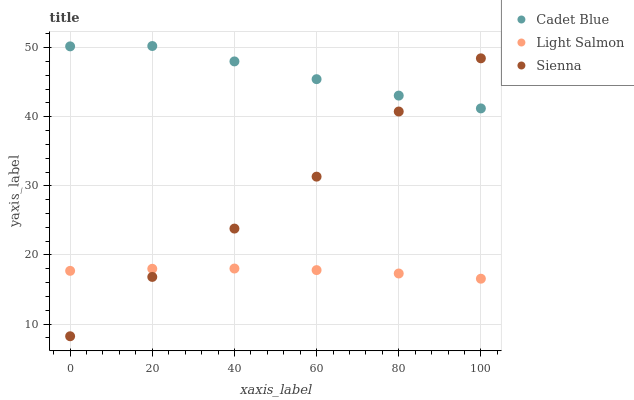Does Light Salmon have the minimum area under the curve?
Answer yes or no. Yes. Does Cadet Blue have the maximum area under the curve?
Answer yes or no. Yes. Does Cadet Blue have the minimum area under the curve?
Answer yes or no. No. Does Light Salmon have the maximum area under the curve?
Answer yes or no. No. Is Light Salmon the smoothest?
Answer yes or no. Yes. Is Sienna the roughest?
Answer yes or no. Yes. Is Cadet Blue the smoothest?
Answer yes or no. No. Is Cadet Blue the roughest?
Answer yes or no. No. Does Sienna have the lowest value?
Answer yes or no. Yes. Does Light Salmon have the lowest value?
Answer yes or no. No. Does Cadet Blue have the highest value?
Answer yes or no. Yes. Does Light Salmon have the highest value?
Answer yes or no. No. Is Light Salmon less than Cadet Blue?
Answer yes or no. Yes. Is Cadet Blue greater than Light Salmon?
Answer yes or no. Yes. Does Light Salmon intersect Sienna?
Answer yes or no. Yes. Is Light Salmon less than Sienna?
Answer yes or no. No. Is Light Salmon greater than Sienna?
Answer yes or no. No. Does Light Salmon intersect Cadet Blue?
Answer yes or no. No. 